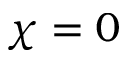<formula> <loc_0><loc_0><loc_500><loc_500>\chi = 0</formula> 